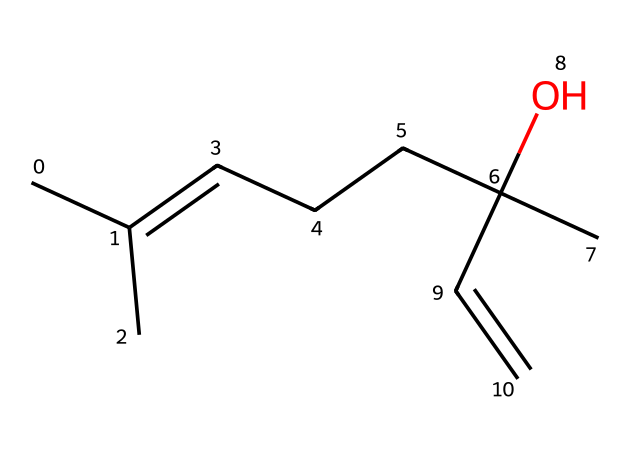what is the total number of carbon atoms in this compound? The SMILES representation shows a branched structure with various carbon atoms. By analyzing the structure, you can count a total of 10 carbon atoms.
Answer: 10 how many double bonds are present in this chemical? Looking at the SMILES and considering the structure, there is one double bond indicated in the between the two carbon atoms marked with 'C=C'.
Answer: 1 what is the functional group present in this structure? The 'O' in the SMILES indicates the presence of a hydroxyl group, which is characteristic of alcohols. Hence, the functional group is an alcohol.
Answer: alcohol identify the molecular formula of linalool. By counting each type of atom from the SMILES representation, the molecular formula is determined as C10H18O.
Answer: C10H18O does this compound fall under the category of terpenes? Linalool is known to be classified as a terpene due to its structure and natural occurrence. Its presence in essential oils supports that classification.
Answer: yes what type of scent is commonly associated with linalool? Linalool is well known for its floral scent, which is prominent in various personal care products.
Answer: floral 